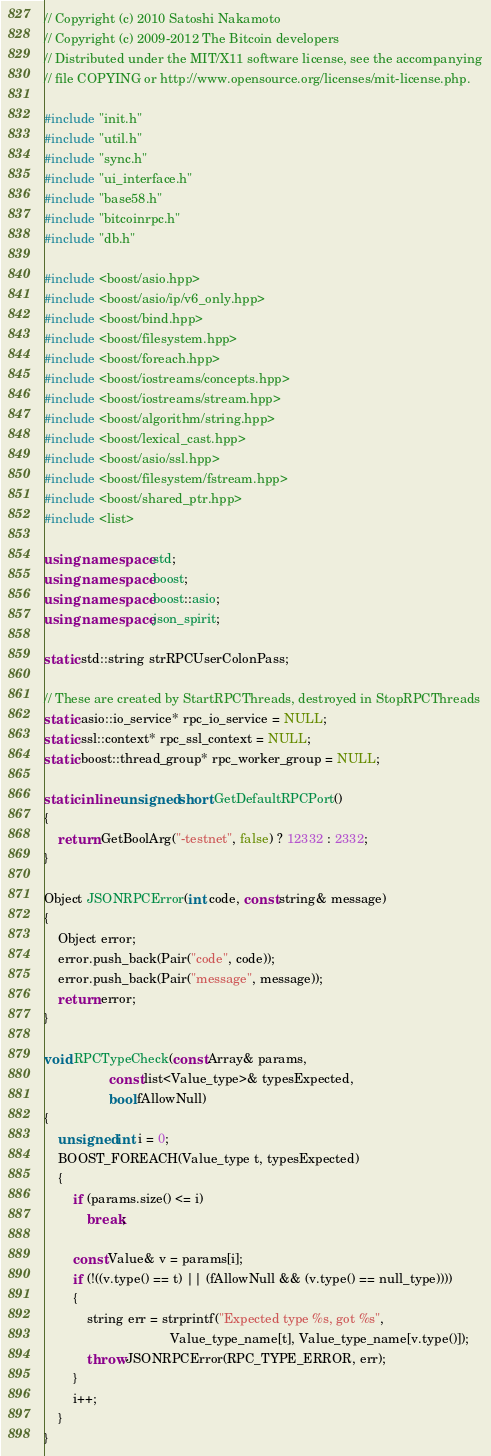Convert code to text. <code><loc_0><loc_0><loc_500><loc_500><_C++_>// Copyright (c) 2010 Satoshi Nakamoto
// Copyright (c) 2009-2012 The Bitcoin developers
// Distributed under the MIT/X11 software license, see the accompanying
// file COPYING or http://www.opensource.org/licenses/mit-license.php.

#include "init.h"
#include "util.h"
#include "sync.h"
#include "ui_interface.h"
#include "base58.h"
#include "bitcoinrpc.h"
#include "db.h"

#include <boost/asio.hpp>
#include <boost/asio/ip/v6_only.hpp>
#include <boost/bind.hpp>
#include <boost/filesystem.hpp>
#include <boost/foreach.hpp>
#include <boost/iostreams/concepts.hpp>
#include <boost/iostreams/stream.hpp>
#include <boost/algorithm/string.hpp>
#include <boost/lexical_cast.hpp>
#include <boost/asio/ssl.hpp>
#include <boost/filesystem/fstream.hpp>
#include <boost/shared_ptr.hpp>
#include <list>

using namespace std;
using namespace boost;
using namespace boost::asio;
using namespace json_spirit;

static std::string strRPCUserColonPass;

// These are created by StartRPCThreads, destroyed in StopRPCThreads
static asio::io_service* rpc_io_service = NULL;
static ssl::context* rpc_ssl_context = NULL;
static boost::thread_group* rpc_worker_group = NULL;

static inline unsigned short GetDefaultRPCPort()
{
    return GetBoolArg("-testnet", false) ? 12332 : 2332;
}

Object JSONRPCError(int code, const string& message)
{
    Object error;
    error.push_back(Pair("code", code));
    error.push_back(Pair("message", message));
    return error;
}

void RPCTypeCheck(const Array& params,
                  const list<Value_type>& typesExpected,
                  bool fAllowNull)
{
    unsigned int i = 0;
    BOOST_FOREACH(Value_type t, typesExpected)
    {
        if (params.size() <= i)
            break;

        const Value& v = params[i];
        if (!((v.type() == t) || (fAllowNull && (v.type() == null_type))))
        {
            string err = strprintf("Expected type %s, got %s",
                                   Value_type_name[t], Value_type_name[v.type()]);
            throw JSONRPCError(RPC_TYPE_ERROR, err);
        }
        i++;
    }
}
</code> 